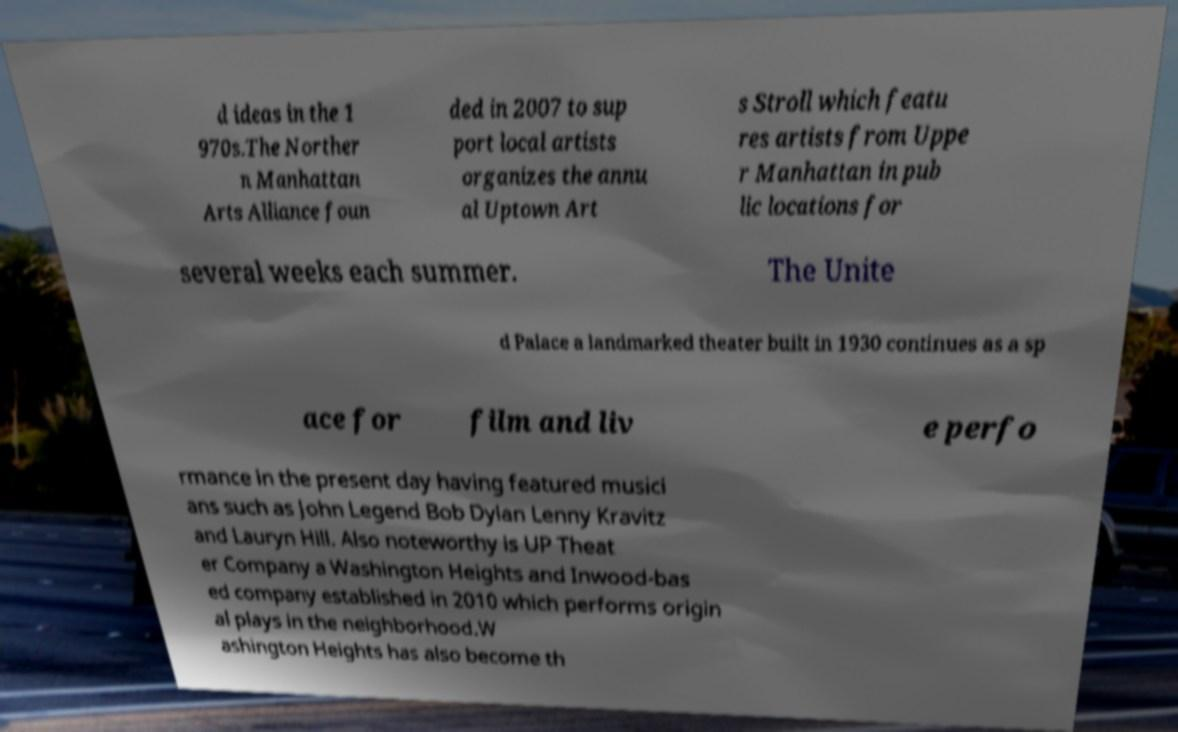Can you read and provide the text displayed in the image?This photo seems to have some interesting text. Can you extract and type it out for me? d ideas in the 1 970s.The Norther n Manhattan Arts Alliance foun ded in 2007 to sup port local artists organizes the annu al Uptown Art s Stroll which featu res artists from Uppe r Manhattan in pub lic locations for several weeks each summer. The Unite d Palace a landmarked theater built in 1930 continues as a sp ace for film and liv e perfo rmance in the present day having featured musici ans such as John Legend Bob Dylan Lenny Kravitz and Lauryn Hill. Also noteworthy is UP Theat er Company a Washington Heights and Inwood-bas ed company established in 2010 which performs origin al plays in the neighborhood.W ashington Heights has also become th 